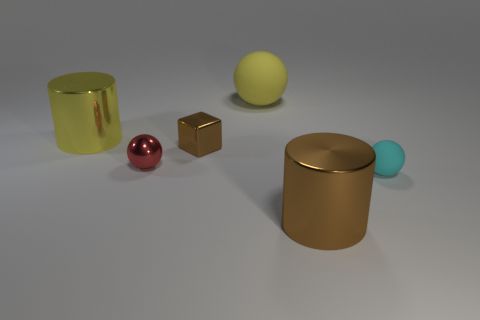Subtract all tiny cyan rubber balls. How many balls are left? 2 Add 3 large yellow metal blocks. How many objects exist? 9 Subtract all red spheres. How many spheres are left? 2 Subtract all cubes. How many objects are left? 5 Subtract all brown cubes. How many brown cylinders are left? 1 Add 6 tiny shiny things. How many tiny shiny things are left? 8 Add 2 big yellow spheres. How many big yellow spheres exist? 3 Subtract 0 blue spheres. How many objects are left? 6 Subtract all blue balls. Subtract all purple cubes. How many balls are left? 3 Subtract all tiny cyan things. Subtract all tiny brown shiny cubes. How many objects are left? 4 